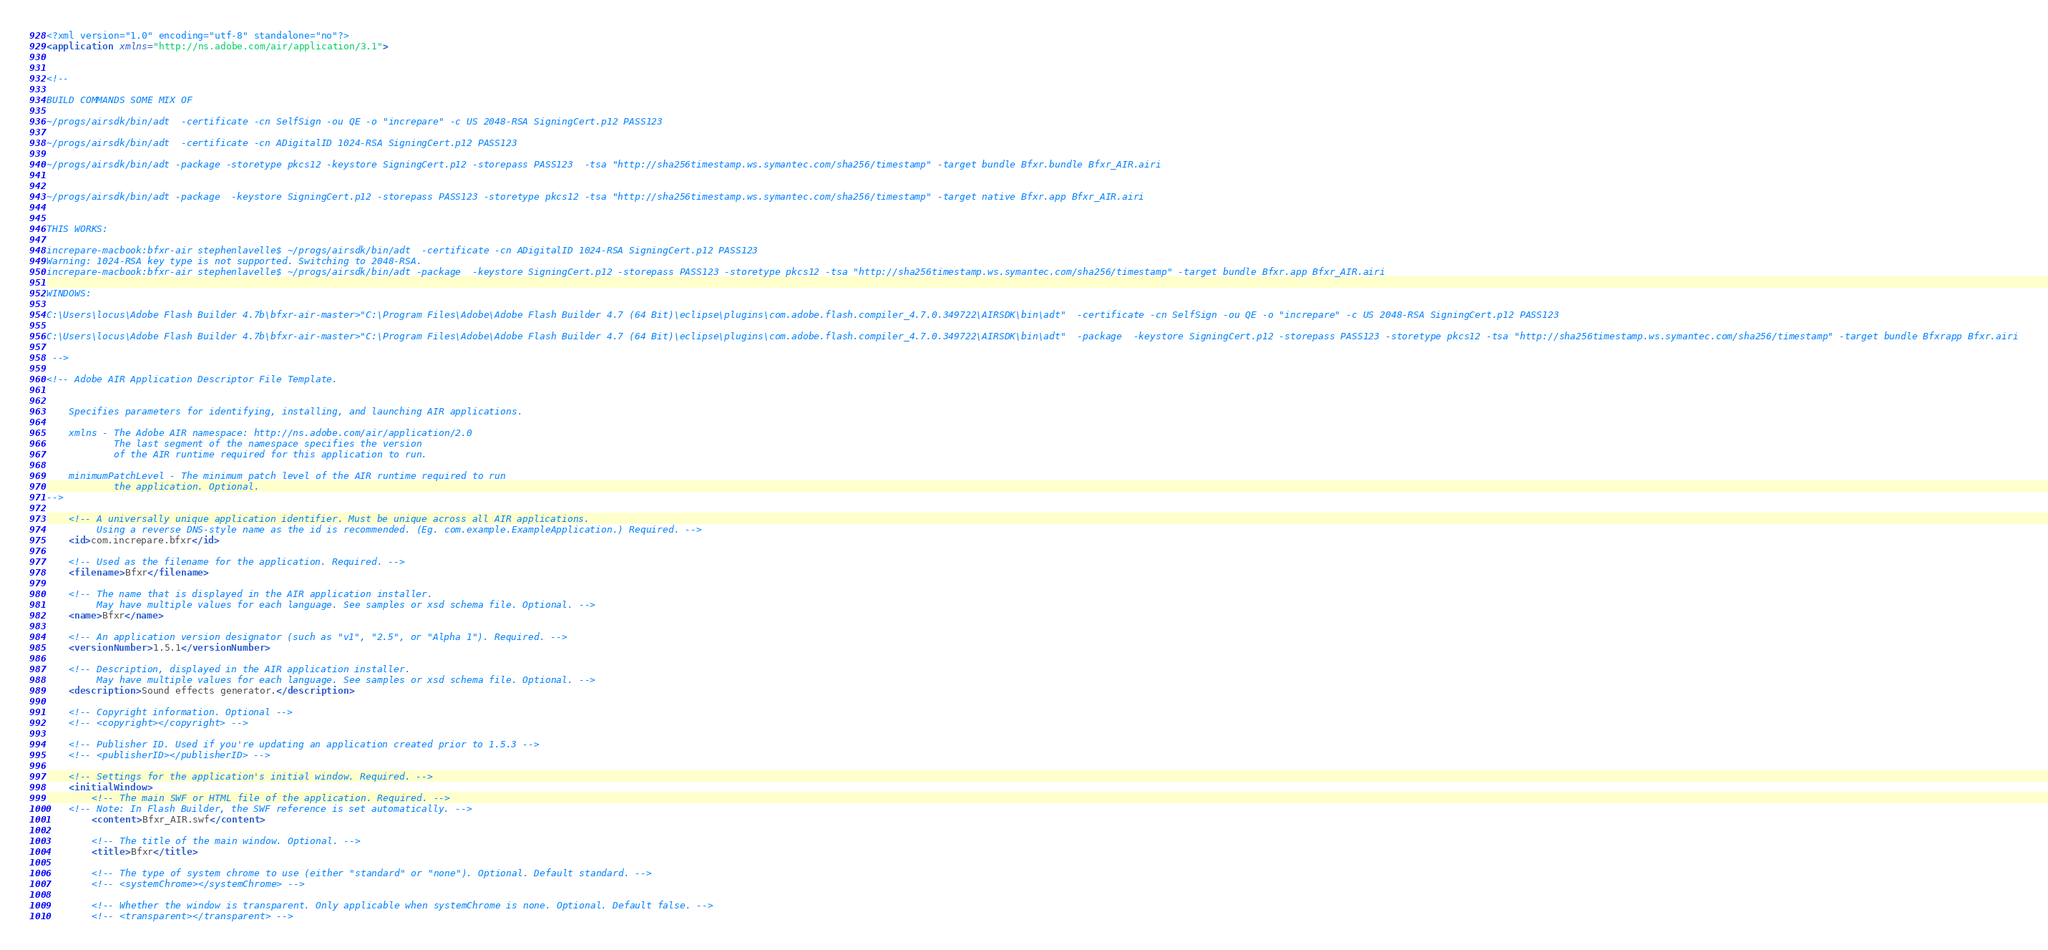<code> <loc_0><loc_0><loc_500><loc_500><_XML_><?xml version="1.0" encoding="utf-8" standalone="no"?>
<application xmlns="http://ns.adobe.com/air/application/3.1">


<!-- 

BUILD COMMANDS SOME MIX OF

~/progs/airsdk/bin/adt  -certificate -cn SelfSign -ou QE -o "increpare" -c US 2048-RSA SigningCert.p12 PASS123 

~/progs/airsdk/bin/adt  -certificate -cn ADigitalID 1024-RSA SigningCert.p12 PASS123

~/progs/airsdk/bin/adt -package -storetype pkcs12 -keystore SigningCert.p12 -storepass PASS123  -tsa "http://sha256timestamp.ws.symantec.com/sha256/timestamp" -target bundle Bfxr.bundle Bfxr_AIR.airi


~/progs/airsdk/bin/adt -package  -keystore SigningCert.p12 -storepass PASS123 -storetype pkcs12 -tsa "http://sha256timestamp.ws.symantec.com/sha256/timestamp" -target native Bfxr.app Bfxr_AIR.airi


THIS WORKS:

increpare-macbook:bfxr-air stephenlavelle$ ~/progs/airsdk/bin/adt  -certificate -cn ADigitalID 1024-RSA SigningCert.p12 PASS123
Warning: 1024-RSA key type is not supported. Switching to 2048-RSA.
increpare-macbook:bfxr-air stephenlavelle$ ~/progs/airsdk/bin/adt -package  -keystore SigningCert.p12 -storepass PASS123 -storetype pkcs12 -tsa "http://sha256timestamp.ws.symantec.com/sha256/timestamp" -target bundle Bfxr.app Bfxr_AIR.airi

WINDOWS:

C:\Users\locus\Adobe Flash Builder 4.7b\bfxr-air-master>"C:\Program Files\Adobe\Adobe Flash Builder 4.7 (64 Bit)\eclipse\plugins\com.adobe.flash.compiler_4.7.0.349722\AIRSDK\bin\adt"  -certificate -cn SelfSign -ou QE -o "increpare" -c US 2048-RSA SigningCert.p12 PASS123

C:\Users\locus\Adobe Flash Builder 4.7b\bfxr-air-master>"C:\Program Files\Adobe\Adobe Flash Builder 4.7 (64 Bit)\eclipse\plugins\com.adobe.flash.compiler_4.7.0.349722\AIRSDK\bin\adt"  -package  -keystore SigningCert.p12 -storepass PASS123 -storetype pkcs12 -tsa "http://sha256timestamp.ws.symantec.com/sha256/timestamp" -target bundle Bfxrapp Bfxr.airi

 -->
 
<!-- Adobe AIR Application Descriptor File Template.


	Specifies parameters for identifying, installing, and launching AIR applications.

	xmlns - The Adobe AIR namespace: http://ns.adobe.com/air/application/2.0
			The last segment of the namespace specifies the version 
			of the AIR runtime required for this application to run.
			
	minimumPatchLevel - The minimum patch level of the AIR runtime required to run 
			the application. Optional.
-->

	<!-- A universally unique application identifier. Must be unique across all AIR applications.
	     Using a reverse DNS-style name as the id is recommended. (Eg. com.example.ExampleApplication.) Required. -->
	<id>com.increpare.bfxr</id>

	<!-- Used as the filename for the application. Required. -->
	<filename>Bfxr</filename>

	<!-- The name that is displayed in the AIR application installer. 
	     May have multiple values for each language. See samples or xsd schema file. Optional. -->
	<name>Bfxr</name>

	<!-- An application version designator (such as "v1", "2.5", or "Alpha 1"). Required. -->
	<versionNumber>1.5.1</versionNumber>

	<!-- Description, displayed in the AIR application installer.
	     May have multiple values for each language. See samples or xsd schema file. Optional. -->
	<description>Sound effects generator.</description>

	<!-- Copyright information. Optional -->
	<!-- <copyright></copyright> -->

	<!-- Publisher ID. Used if you're updating an application created prior to 1.5.3 -->
	<!-- <publisherID></publisherID> -->

	<!-- Settings for the application's initial window. Required. -->
	<initialWindow>
		<!-- The main SWF or HTML file of the application. Required. -->
	<!-- Note: In Flash Builder, the SWF reference is set automatically. -->
		<content>Bfxr_AIR.swf</content>
		
		<!-- The title of the main window. Optional. -->
		<title>Bfxr</title>

		<!-- The type of system chrome to use (either "standard" or "none"). Optional. Default standard. -->
		<!-- <systemChrome></systemChrome> -->

		<!-- Whether the window is transparent. Only applicable when systemChrome is none. Optional. Default false. -->
		<!-- <transparent></transparent> -->
</code> 